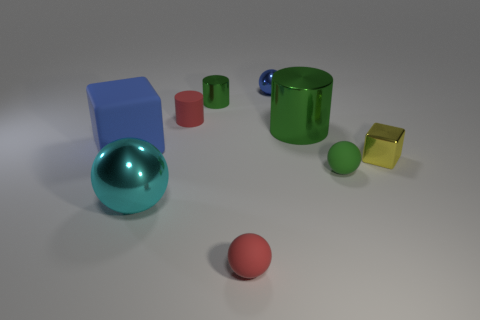Subtract 1 balls. How many balls are left? 3 Subtract all gray balls. Subtract all red cubes. How many balls are left? 4 Subtract all cylinders. How many objects are left? 6 Subtract 0 gray cylinders. How many objects are left? 9 Subtract all metallic blocks. Subtract all blue cubes. How many objects are left? 7 Add 2 matte cubes. How many matte cubes are left? 3 Add 1 yellow shiny blocks. How many yellow shiny blocks exist? 2 